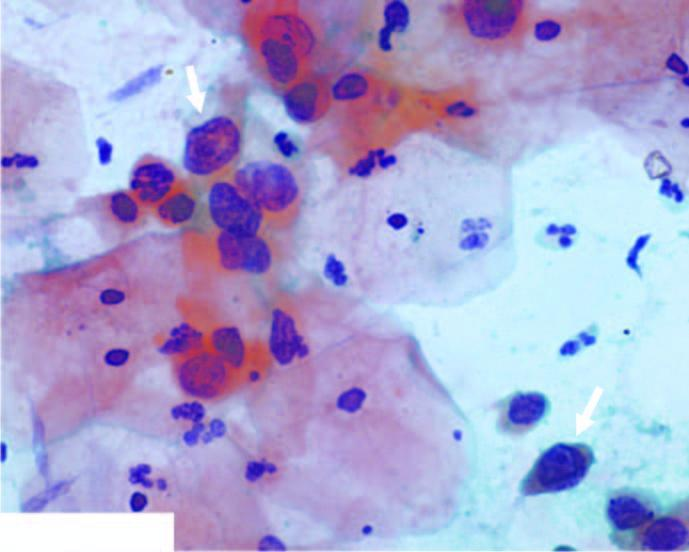what does the background show?
Answer the question using a single word or phrase. Numerous pmns 